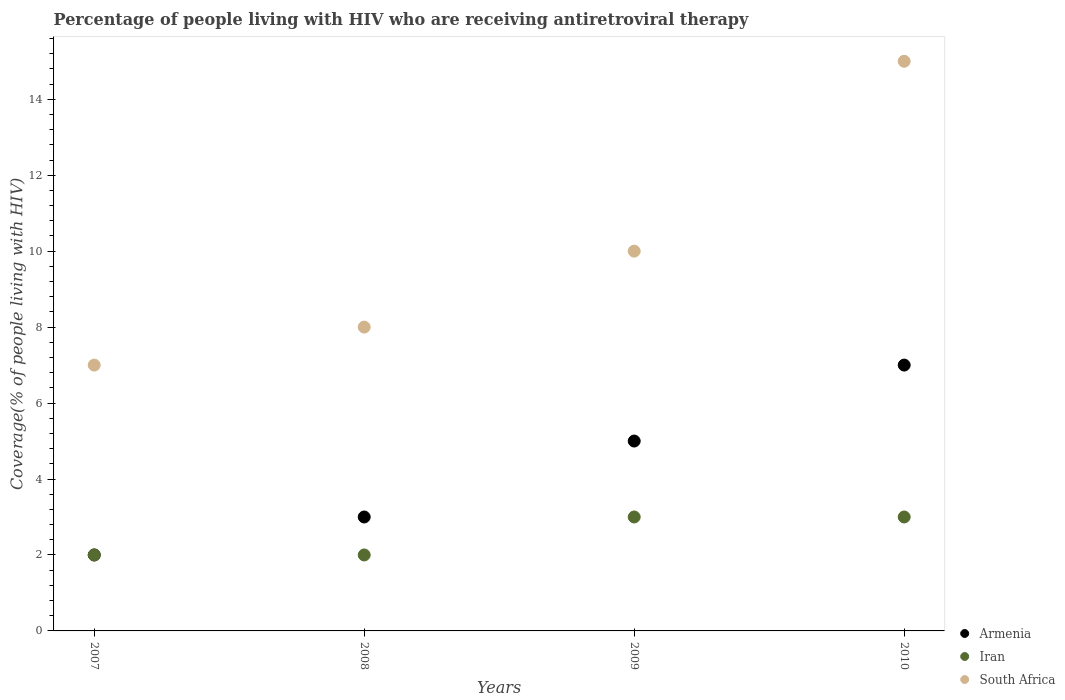What is the percentage of the HIV infected people who are receiving antiretroviral therapy in South Africa in 2010?
Give a very brief answer. 15. Across all years, what is the maximum percentage of the HIV infected people who are receiving antiretroviral therapy in South Africa?
Make the answer very short. 15. Across all years, what is the minimum percentage of the HIV infected people who are receiving antiretroviral therapy in Iran?
Offer a very short reply. 2. In which year was the percentage of the HIV infected people who are receiving antiretroviral therapy in Iran maximum?
Provide a short and direct response. 2009. What is the total percentage of the HIV infected people who are receiving antiretroviral therapy in Iran in the graph?
Keep it short and to the point. 10. What is the difference between the percentage of the HIV infected people who are receiving antiretroviral therapy in Iran in 2008 and that in 2009?
Offer a terse response. -1. What is the difference between the percentage of the HIV infected people who are receiving antiretroviral therapy in South Africa in 2007 and the percentage of the HIV infected people who are receiving antiretroviral therapy in Iran in 2009?
Ensure brevity in your answer.  4. What is the average percentage of the HIV infected people who are receiving antiretroviral therapy in Armenia per year?
Give a very brief answer. 4.25. In the year 2010, what is the difference between the percentage of the HIV infected people who are receiving antiretroviral therapy in Iran and percentage of the HIV infected people who are receiving antiretroviral therapy in Armenia?
Your answer should be compact. -4. In how many years, is the percentage of the HIV infected people who are receiving antiretroviral therapy in Iran greater than 1.2000000000000002 %?
Ensure brevity in your answer.  4. What is the ratio of the percentage of the HIV infected people who are receiving antiretroviral therapy in Iran in 2007 to that in 2010?
Your response must be concise. 0.67. Is the percentage of the HIV infected people who are receiving antiretroviral therapy in Iran in 2009 less than that in 2010?
Provide a short and direct response. No. Is the difference between the percentage of the HIV infected people who are receiving antiretroviral therapy in Iran in 2008 and 2010 greater than the difference between the percentage of the HIV infected people who are receiving antiretroviral therapy in Armenia in 2008 and 2010?
Your response must be concise. Yes. What is the difference between the highest and the lowest percentage of the HIV infected people who are receiving antiretroviral therapy in Iran?
Offer a terse response. 1. Is the sum of the percentage of the HIV infected people who are receiving antiretroviral therapy in Iran in 2008 and 2010 greater than the maximum percentage of the HIV infected people who are receiving antiretroviral therapy in South Africa across all years?
Provide a succinct answer. No. Is it the case that in every year, the sum of the percentage of the HIV infected people who are receiving antiretroviral therapy in Armenia and percentage of the HIV infected people who are receiving antiretroviral therapy in Iran  is greater than the percentage of the HIV infected people who are receiving antiretroviral therapy in South Africa?
Provide a succinct answer. No. Does the percentage of the HIV infected people who are receiving antiretroviral therapy in Iran monotonically increase over the years?
Give a very brief answer. No. Is the percentage of the HIV infected people who are receiving antiretroviral therapy in South Africa strictly less than the percentage of the HIV infected people who are receiving antiretroviral therapy in Iran over the years?
Make the answer very short. No. What is the difference between two consecutive major ticks on the Y-axis?
Make the answer very short. 2. Does the graph contain any zero values?
Ensure brevity in your answer.  No. Does the graph contain grids?
Ensure brevity in your answer.  No. How are the legend labels stacked?
Your response must be concise. Vertical. What is the title of the graph?
Ensure brevity in your answer.  Percentage of people living with HIV who are receiving antiretroviral therapy. Does "Marshall Islands" appear as one of the legend labels in the graph?
Keep it short and to the point. No. What is the label or title of the Y-axis?
Make the answer very short. Coverage(% of people living with HIV). What is the Coverage(% of people living with HIV) of Armenia in 2007?
Ensure brevity in your answer.  2. What is the Coverage(% of people living with HIV) in South Africa in 2007?
Give a very brief answer. 7. What is the Coverage(% of people living with HIV) in Armenia in 2008?
Make the answer very short. 3. What is the Coverage(% of people living with HIV) of South Africa in 2008?
Provide a short and direct response. 8. What is the Coverage(% of people living with HIV) in Armenia in 2010?
Give a very brief answer. 7. What is the Coverage(% of people living with HIV) of Iran in 2010?
Provide a succinct answer. 3. What is the Coverage(% of people living with HIV) in South Africa in 2010?
Your answer should be very brief. 15. Across all years, what is the maximum Coverage(% of people living with HIV) in Armenia?
Provide a short and direct response. 7. Across all years, what is the maximum Coverage(% of people living with HIV) in Iran?
Offer a terse response. 3. What is the total Coverage(% of people living with HIV) in Armenia in the graph?
Your answer should be very brief. 17. What is the total Coverage(% of people living with HIV) of Iran in the graph?
Your response must be concise. 10. What is the total Coverage(% of people living with HIV) of South Africa in the graph?
Keep it short and to the point. 40. What is the difference between the Coverage(% of people living with HIV) in Armenia in 2007 and that in 2008?
Make the answer very short. -1. What is the difference between the Coverage(% of people living with HIV) of Iran in 2007 and that in 2009?
Ensure brevity in your answer.  -1. What is the difference between the Coverage(% of people living with HIV) of South Africa in 2008 and that in 2009?
Offer a very short reply. -2. What is the difference between the Coverage(% of people living with HIV) in Iran in 2008 and that in 2010?
Keep it short and to the point. -1. What is the difference between the Coverage(% of people living with HIV) in South Africa in 2009 and that in 2010?
Ensure brevity in your answer.  -5. What is the difference between the Coverage(% of people living with HIV) of Armenia in 2007 and the Coverage(% of people living with HIV) of Iran in 2008?
Offer a terse response. 0. What is the difference between the Coverage(% of people living with HIV) in Armenia in 2007 and the Coverage(% of people living with HIV) in South Africa in 2008?
Give a very brief answer. -6. What is the difference between the Coverage(% of people living with HIV) of Iran in 2007 and the Coverage(% of people living with HIV) of South Africa in 2008?
Your answer should be very brief. -6. What is the difference between the Coverage(% of people living with HIV) in Armenia in 2007 and the Coverage(% of people living with HIV) in Iran in 2009?
Give a very brief answer. -1. What is the difference between the Coverage(% of people living with HIV) of Armenia in 2007 and the Coverage(% of people living with HIV) of Iran in 2010?
Keep it short and to the point. -1. What is the difference between the Coverage(% of people living with HIV) in Armenia in 2007 and the Coverage(% of people living with HIV) in South Africa in 2010?
Keep it short and to the point. -13. What is the difference between the Coverage(% of people living with HIV) of Armenia in 2008 and the Coverage(% of people living with HIV) of Iran in 2009?
Provide a short and direct response. 0. What is the difference between the Coverage(% of people living with HIV) in Armenia in 2008 and the Coverage(% of people living with HIV) in South Africa in 2009?
Your answer should be compact. -7. What is the difference between the Coverage(% of people living with HIV) in Iran in 2008 and the Coverage(% of people living with HIV) in South Africa in 2009?
Make the answer very short. -8. What is the difference between the Coverage(% of people living with HIV) in Armenia in 2008 and the Coverage(% of people living with HIV) in South Africa in 2010?
Offer a very short reply. -12. What is the difference between the Coverage(% of people living with HIV) of Iran in 2008 and the Coverage(% of people living with HIV) of South Africa in 2010?
Provide a short and direct response. -13. What is the difference between the Coverage(% of people living with HIV) of Armenia in 2009 and the Coverage(% of people living with HIV) of South Africa in 2010?
Keep it short and to the point. -10. What is the average Coverage(% of people living with HIV) in Armenia per year?
Your response must be concise. 4.25. What is the average Coverage(% of people living with HIV) of Iran per year?
Provide a succinct answer. 2.5. In the year 2007, what is the difference between the Coverage(% of people living with HIV) of Armenia and Coverage(% of people living with HIV) of Iran?
Give a very brief answer. 0. In the year 2007, what is the difference between the Coverage(% of people living with HIV) of Armenia and Coverage(% of people living with HIV) of South Africa?
Provide a short and direct response. -5. In the year 2007, what is the difference between the Coverage(% of people living with HIV) in Iran and Coverage(% of people living with HIV) in South Africa?
Offer a very short reply. -5. In the year 2008, what is the difference between the Coverage(% of people living with HIV) of Armenia and Coverage(% of people living with HIV) of Iran?
Offer a terse response. 1. In the year 2008, what is the difference between the Coverage(% of people living with HIV) in Iran and Coverage(% of people living with HIV) in South Africa?
Offer a very short reply. -6. In the year 2009, what is the difference between the Coverage(% of people living with HIV) of Armenia and Coverage(% of people living with HIV) of Iran?
Your answer should be compact. 2. In the year 2009, what is the difference between the Coverage(% of people living with HIV) in Armenia and Coverage(% of people living with HIV) in South Africa?
Your response must be concise. -5. In the year 2009, what is the difference between the Coverage(% of people living with HIV) of Iran and Coverage(% of people living with HIV) of South Africa?
Your answer should be very brief. -7. In the year 2010, what is the difference between the Coverage(% of people living with HIV) in Armenia and Coverage(% of people living with HIV) in Iran?
Make the answer very short. 4. In the year 2010, what is the difference between the Coverage(% of people living with HIV) in Armenia and Coverage(% of people living with HIV) in South Africa?
Provide a short and direct response. -8. What is the ratio of the Coverage(% of people living with HIV) of Armenia in 2007 to that in 2008?
Your answer should be very brief. 0.67. What is the ratio of the Coverage(% of people living with HIV) in Iran in 2007 to that in 2008?
Ensure brevity in your answer.  1. What is the ratio of the Coverage(% of people living with HIV) of South Africa in 2007 to that in 2008?
Offer a terse response. 0.88. What is the ratio of the Coverage(% of people living with HIV) in Iran in 2007 to that in 2009?
Keep it short and to the point. 0.67. What is the ratio of the Coverage(% of people living with HIV) in South Africa in 2007 to that in 2009?
Offer a very short reply. 0.7. What is the ratio of the Coverage(% of people living with HIV) of Armenia in 2007 to that in 2010?
Offer a terse response. 0.29. What is the ratio of the Coverage(% of people living with HIV) in South Africa in 2007 to that in 2010?
Your response must be concise. 0.47. What is the ratio of the Coverage(% of people living with HIV) in Armenia in 2008 to that in 2009?
Keep it short and to the point. 0.6. What is the ratio of the Coverage(% of people living with HIV) of Iran in 2008 to that in 2009?
Keep it short and to the point. 0.67. What is the ratio of the Coverage(% of people living with HIV) in Armenia in 2008 to that in 2010?
Provide a succinct answer. 0.43. What is the ratio of the Coverage(% of people living with HIV) in South Africa in 2008 to that in 2010?
Give a very brief answer. 0.53. What is the ratio of the Coverage(% of people living with HIV) in Armenia in 2009 to that in 2010?
Offer a terse response. 0.71. What is the difference between the highest and the second highest Coverage(% of people living with HIV) in Iran?
Your answer should be very brief. 0. What is the difference between the highest and the second highest Coverage(% of people living with HIV) of South Africa?
Your response must be concise. 5. What is the difference between the highest and the lowest Coverage(% of people living with HIV) of Armenia?
Keep it short and to the point. 5. What is the difference between the highest and the lowest Coverage(% of people living with HIV) in Iran?
Make the answer very short. 1. 